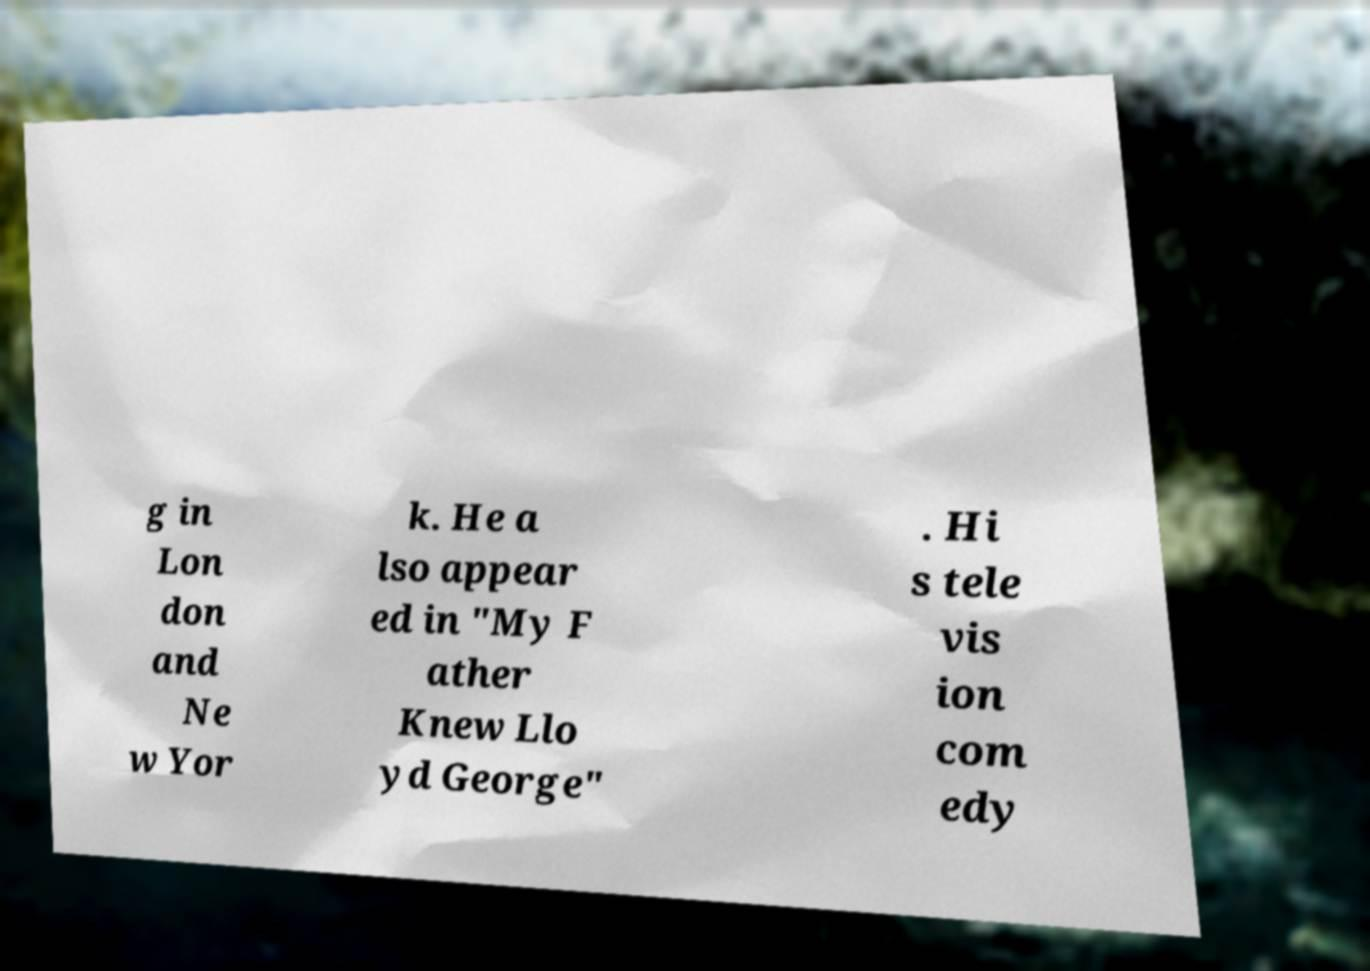Could you extract and type out the text from this image? g in Lon don and Ne w Yor k. He a lso appear ed in "My F ather Knew Llo yd George" . Hi s tele vis ion com edy 